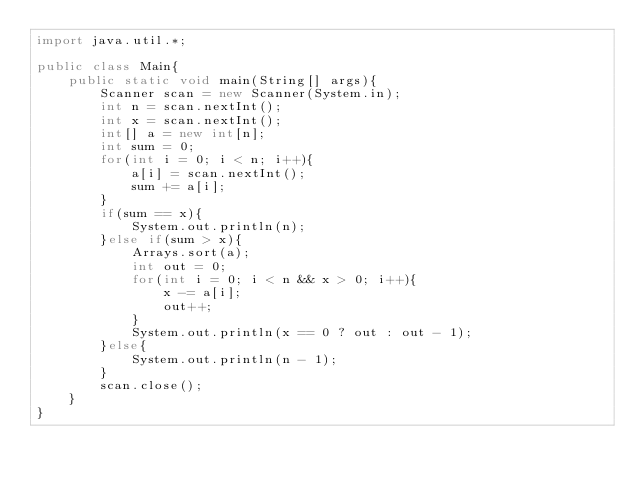<code> <loc_0><loc_0><loc_500><loc_500><_Java_>import java.util.*;

public class Main{
    public static void main(String[] args){
        Scanner scan = new Scanner(System.in);
        int n = scan.nextInt();
        int x = scan.nextInt();
        int[] a = new int[n];
        int sum = 0;
        for(int i = 0; i < n; i++){
            a[i] = scan.nextInt();
            sum += a[i];
        }
        if(sum == x){
            System.out.println(n);
        }else if(sum > x){
            Arrays.sort(a);
            int out = 0;
            for(int i = 0; i < n && x > 0; i++){
                x -= a[i];
                out++;
            }
            System.out.println(x == 0 ? out : out - 1);
        }else{
            System.out.println(n - 1);
        }
        scan.close();
    }
}</code> 